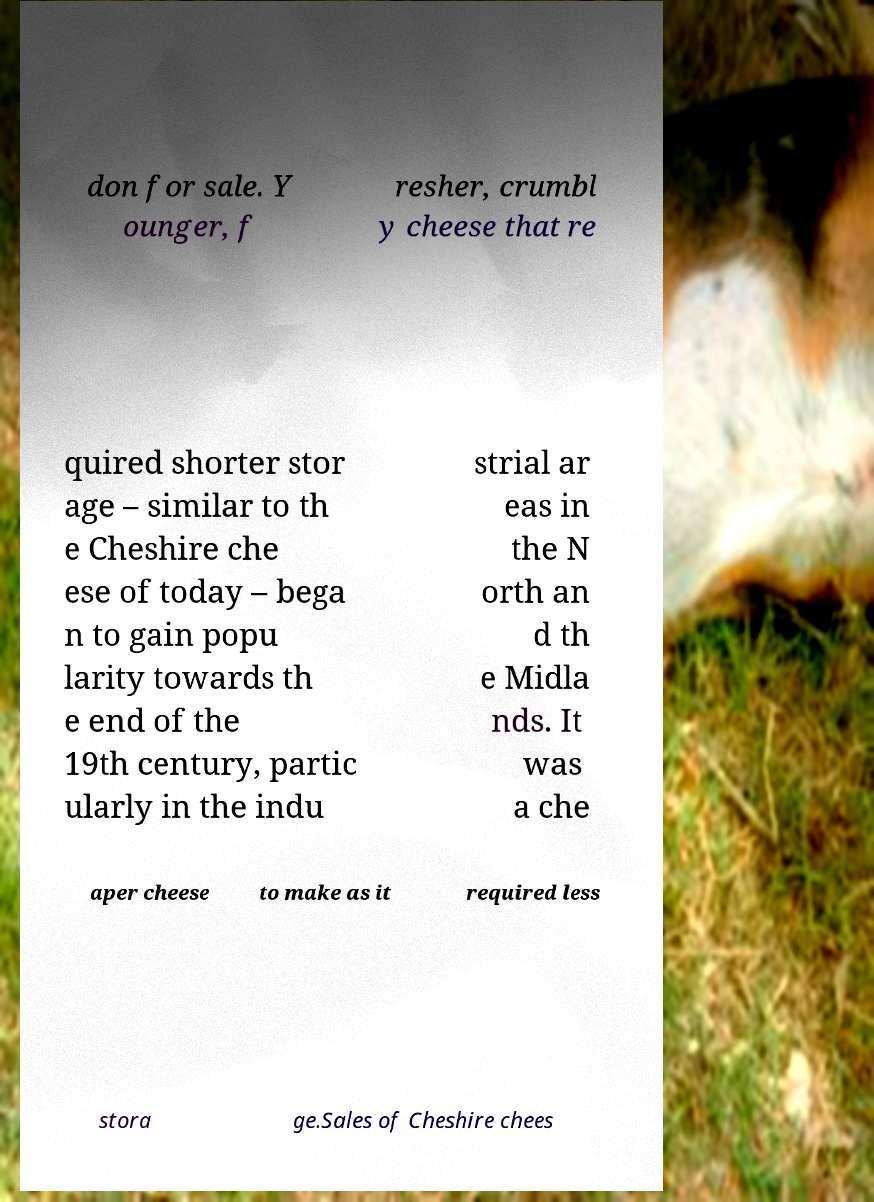Can you accurately transcribe the text from the provided image for me? don for sale. Y ounger, f resher, crumbl y cheese that re quired shorter stor age – similar to th e Cheshire che ese of today – bega n to gain popu larity towards th e end of the 19th century, partic ularly in the indu strial ar eas in the N orth an d th e Midla nds. It was a che aper cheese to make as it required less stora ge.Sales of Cheshire chees 